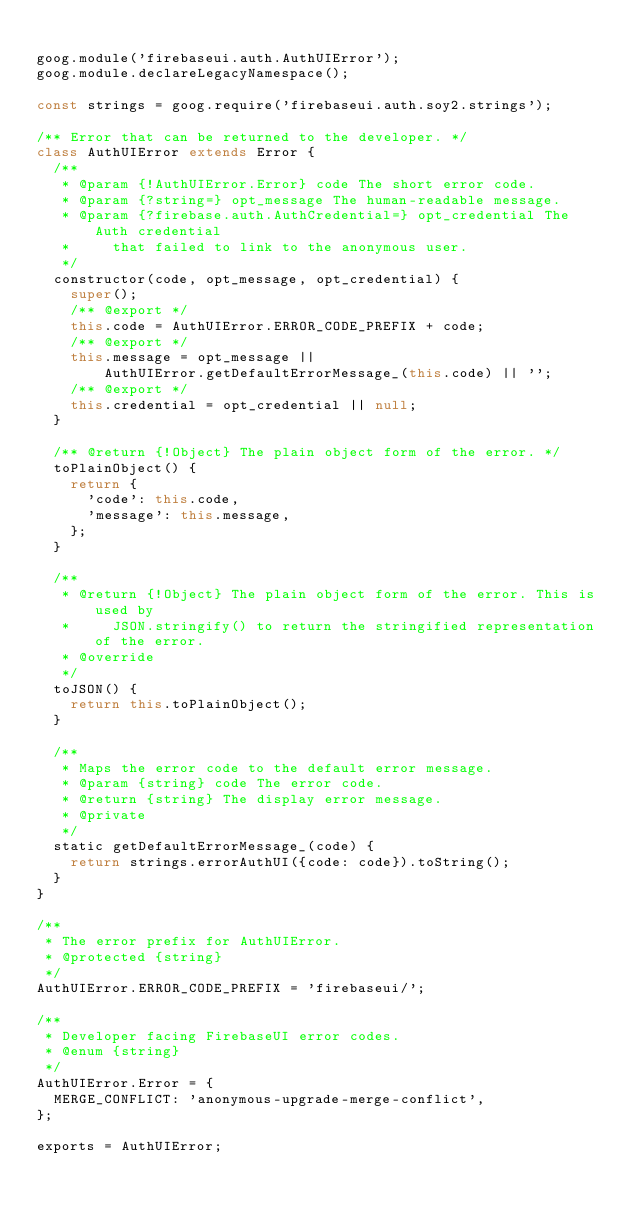<code> <loc_0><loc_0><loc_500><loc_500><_JavaScript_>
goog.module('firebaseui.auth.AuthUIError');
goog.module.declareLegacyNamespace();

const strings = goog.require('firebaseui.auth.soy2.strings');

/** Error that can be returned to the developer. */
class AuthUIError extends Error {
  /**
   * @param {!AuthUIError.Error} code The short error code.
   * @param {?string=} opt_message The human-readable message.
   * @param {?firebase.auth.AuthCredential=} opt_credential The Auth credential
   *     that failed to link to the anonymous user.
   */
  constructor(code, opt_message, opt_credential) {
    super();
    /** @export */
    this.code = AuthUIError.ERROR_CODE_PREFIX + code;
    /** @export */
    this.message = opt_message ||
        AuthUIError.getDefaultErrorMessage_(this.code) || '';
    /** @export */
    this.credential = opt_credential || null;
  }

  /** @return {!Object} The plain object form of the error. */
  toPlainObject() {
    return {
      'code': this.code,
      'message': this.message,
    };
  }

  /**
   * @return {!Object} The plain object form of the error. This is used by
   *     JSON.stringify() to return the stringified representation of the error.
   * @override
   */
  toJSON() {
    return this.toPlainObject();
  }

  /**
   * Maps the error code to the default error message.
   * @param {string} code The error code.
   * @return {string} The display error message.
   * @private
   */
  static getDefaultErrorMessage_(code) {
    return strings.errorAuthUI({code: code}).toString();
  }
}

/**
 * The error prefix for AuthUIError.
 * @protected {string}
 */
AuthUIError.ERROR_CODE_PREFIX = 'firebaseui/';

/**
 * Developer facing FirebaseUI error codes.
 * @enum {string}
 */
AuthUIError.Error = {
  MERGE_CONFLICT: 'anonymous-upgrade-merge-conflict',
};

exports = AuthUIError;
</code> 